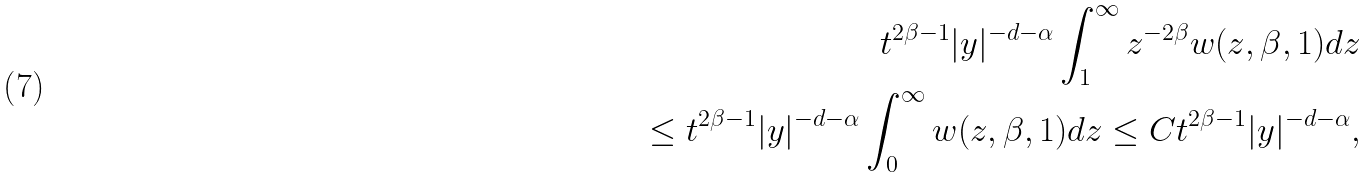<formula> <loc_0><loc_0><loc_500><loc_500>t ^ { 2 \beta - 1 } | y | ^ { - d - \alpha } \int _ { 1 } ^ { \infty } z ^ { - 2 \beta } w ( z , \beta , 1 ) d z \\ \leq t ^ { 2 \beta - 1 } | y | ^ { - d - \alpha } \int _ { 0 } ^ { \infty } w ( z , \beta , 1 ) d z \leq C t ^ { 2 \beta - 1 } | y | ^ { - d - \alpha } ,</formula> 